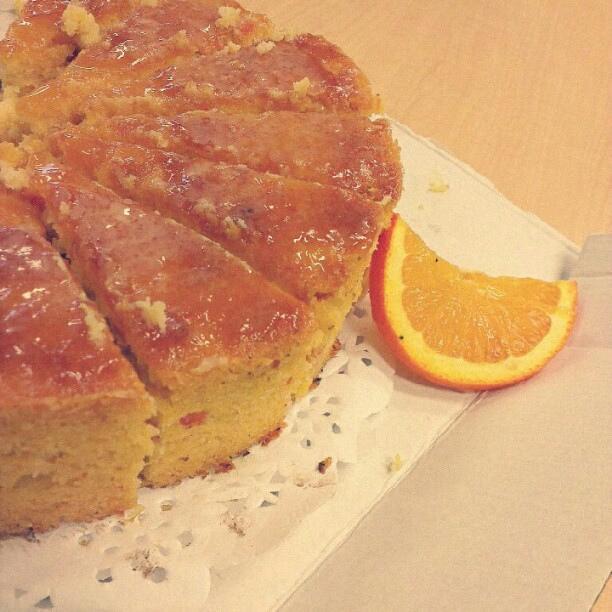How many dining tables are there?
Give a very brief answer. 1. 